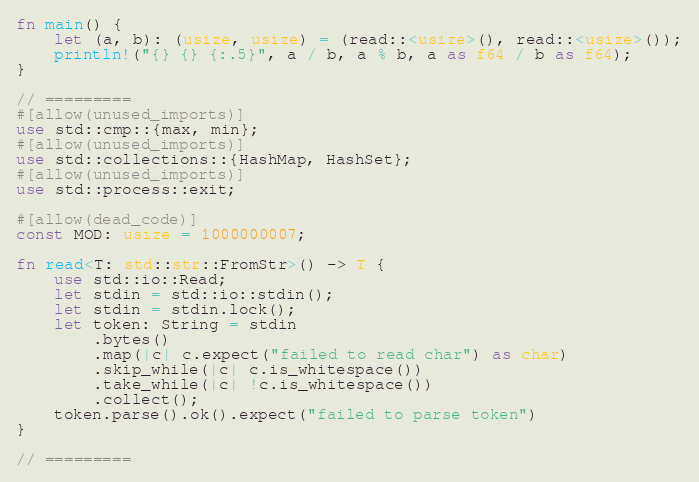<code> <loc_0><loc_0><loc_500><loc_500><_Rust_>fn main() {
    let (a, b): (usize, usize) = (read::<usize>(), read::<usize>());
    println!("{} {} {:.5}", a / b, a % b, a as f64 / b as f64);
}

// =========
#[allow(unused_imports)]
use std::cmp::{max, min};
#[allow(unused_imports)]
use std::collections::{HashMap, HashSet};
#[allow(unused_imports)]
use std::process::exit;

#[allow(dead_code)]
const MOD: usize = 1000000007;

fn read<T: std::str::FromStr>() -> T {
    use std::io::Read;
    let stdin = std::io::stdin();
    let stdin = stdin.lock();
    let token: String = stdin
        .bytes()
        .map(|c| c.expect("failed to read char") as char)
        .skip_while(|c| c.is_whitespace())
        .take_while(|c| !c.is_whitespace())
        .collect();
    token.parse().ok().expect("failed to parse token")
}

// =========

</code> 